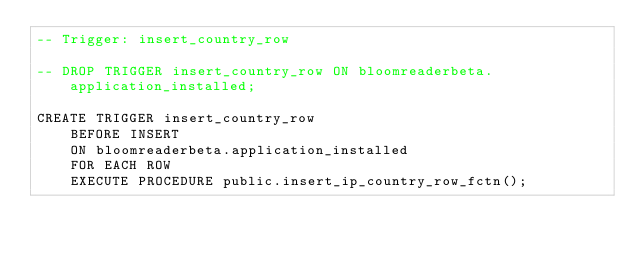<code> <loc_0><loc_0><loc_500><loc_500><_SQL_>-- Trigger: insert_country_row 

-- DROP TRIGGER insert_country_row ON bloomreaderbeta.application_installed;

CREATE TRIGGER insert_country_row 
    BEFORE INSERT
    ON bloomreaderbeta.application_installed
    FOR EACH ROW
    EXECUTE PROCEDURE public.insert_ip_country_row_fctn();</code> 